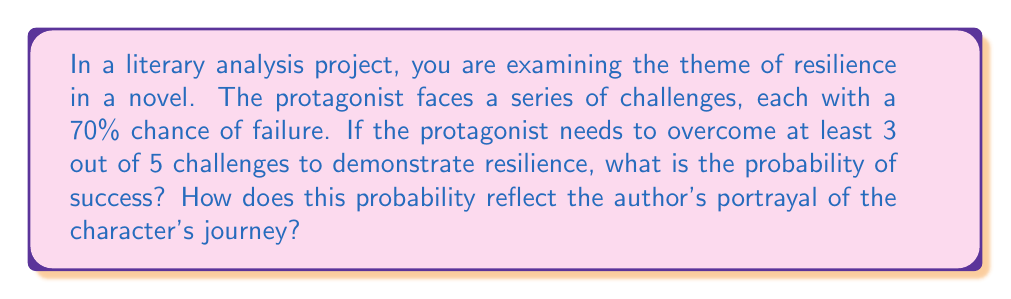Teach me how to tackle this problem. Let's approach this step-by-step:

1) First, we need to calculate the probability of success for a single challenge:
   $P(\text{success}) = 1 - P(\text{failure}) = 1 - 0.70 = 0.30$ or 30%

2) Now, we're looking for the probability of succeeding in at least 3 out of 5 challenges. This can be calculated using the binomial probability formula:

   $$P(X \geq 3) = \sum_{k=3}^{5} \binom{5}{k} p^k (1-p)^{5-k}$$

   Where $p = 0.30$ (probability of success on a single trial)

3) Let's calculate each term:

   For $k = 3$: $\binom{5}{3} (0.30)^3 (0.70)^2 = 10 \times 0.027 \times 0.49 = 0.1323$
   
   For $k = 4$: $\binom{5}{4} (0.30)^4 (0.70)^1 = 5 \times 0.0081 \times 0.70 = 0.02835$
   
   For $k = 5$: $\binom{5}{5} (0.30)^5 (0.70)^0 = 1 \times 0.00243 \times 1 = 0.00243$

4) Sum these probabilities:

   $P(X \geq 3) = 0.1323 + 0.02835 + 0.00243 = 0.16308$

5) Convert to a percentage: $0.16308 \times 100 = 16.308\%$

This probability reflects the author's portrayal of the character's journey as a challenging one, where success is possible but not guaranteed. The relatively low probability (about 16.3%) of overcoming at least 3 out of 5 challenges underscores the difficulty of the protagonist's path, emphasizing the themes of resilience and perseverance in the face of adversity.
Answer: 16.308% 